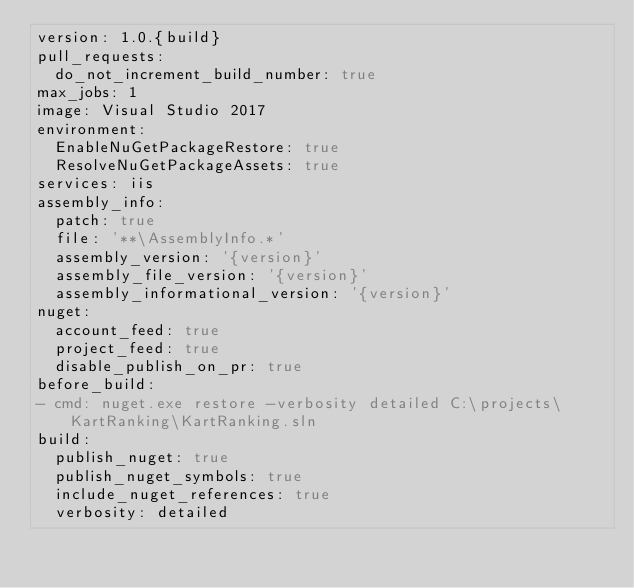Convert code to text. <code><loc_0><loc_0><loc_500><loc_500><_YAML_>version: 1.0.{build}
pull_requests:
  do_not_increment_build_number: true
max_jobs: 1
image: Visual Studio 2017
environment:
  EnableNuGetPackageRestore: true
  ResolveNuGetPackageAssets: true
services: iis
assembly_info:
  patch: true
  file: '**\AssemblyInfo.*'
  assembly_version: '{version}'
  assembly_file_version: '{version}'
  assembly_informational_version: '{version}'
nuget:
  account_feed: true
  project_feed: true
  disable_publish_on_pr: true
before_build:
- cmd: nuget.exe restore -verbosity detailed C:\projects\KartRanking\KartRanking.sln
build:
  publish_nuget: true
  publish_nuget_symbols: true
  include_nuget_references: true
  verbosity: detailed</code> 